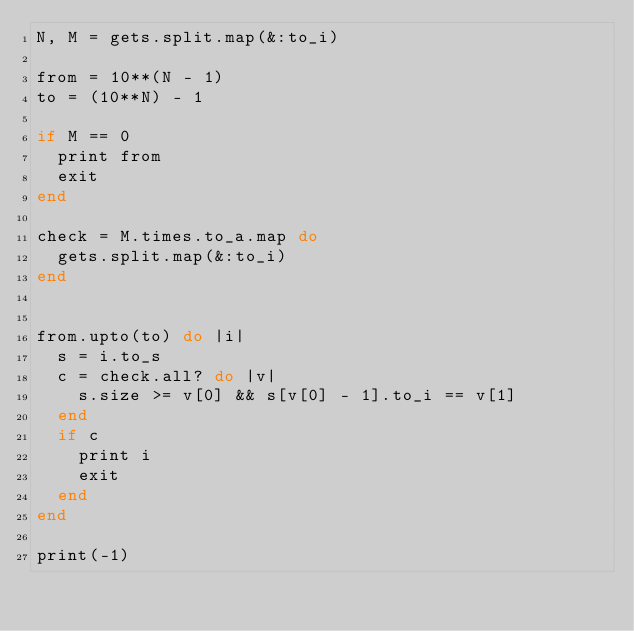Convert code to text. <code><loc_0><loc_0><loc_500><loc_500><_Ruby_>N, M = gets.split.map(&:to_i)

from = 10**(N - 1)
to = (10**N) - 1

if M == 0
  print from
  exit
end

check = M.times.to_a.map do
  gets.split.map(&:to_i)
end


from.upto(to) do |i|
  s = i.to_s
  c = check.all? do |v|
    s.size >= v[0] && s[v[0] - 1].to_i == v[1]
  end
  if c
    print i
    exit
  end
end

print(-1)
</code> 